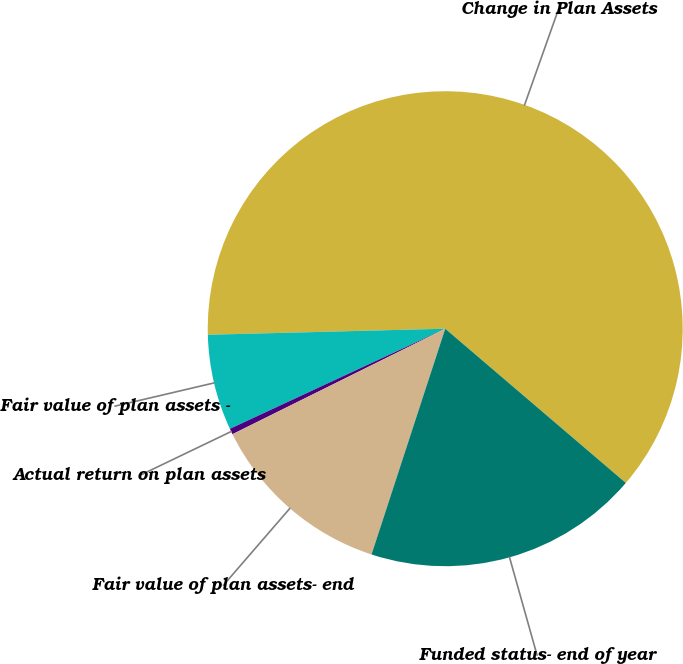Convert chart to OTSL. <chart><loc_0><loc_0><loc_500><loc_500><pie_chart><fcel>Change in Plan Assets<fcel>Fair value of plan assets -<fcel>Actual return on plan assets<fcel>Fair value of plan assets- end<fcel>Funded status- end of year<nl><fcel>61.65%<fcel>6.52%<fcel>0.4%<fcel>12.65%<fcel>18.77%<nl></chart> 